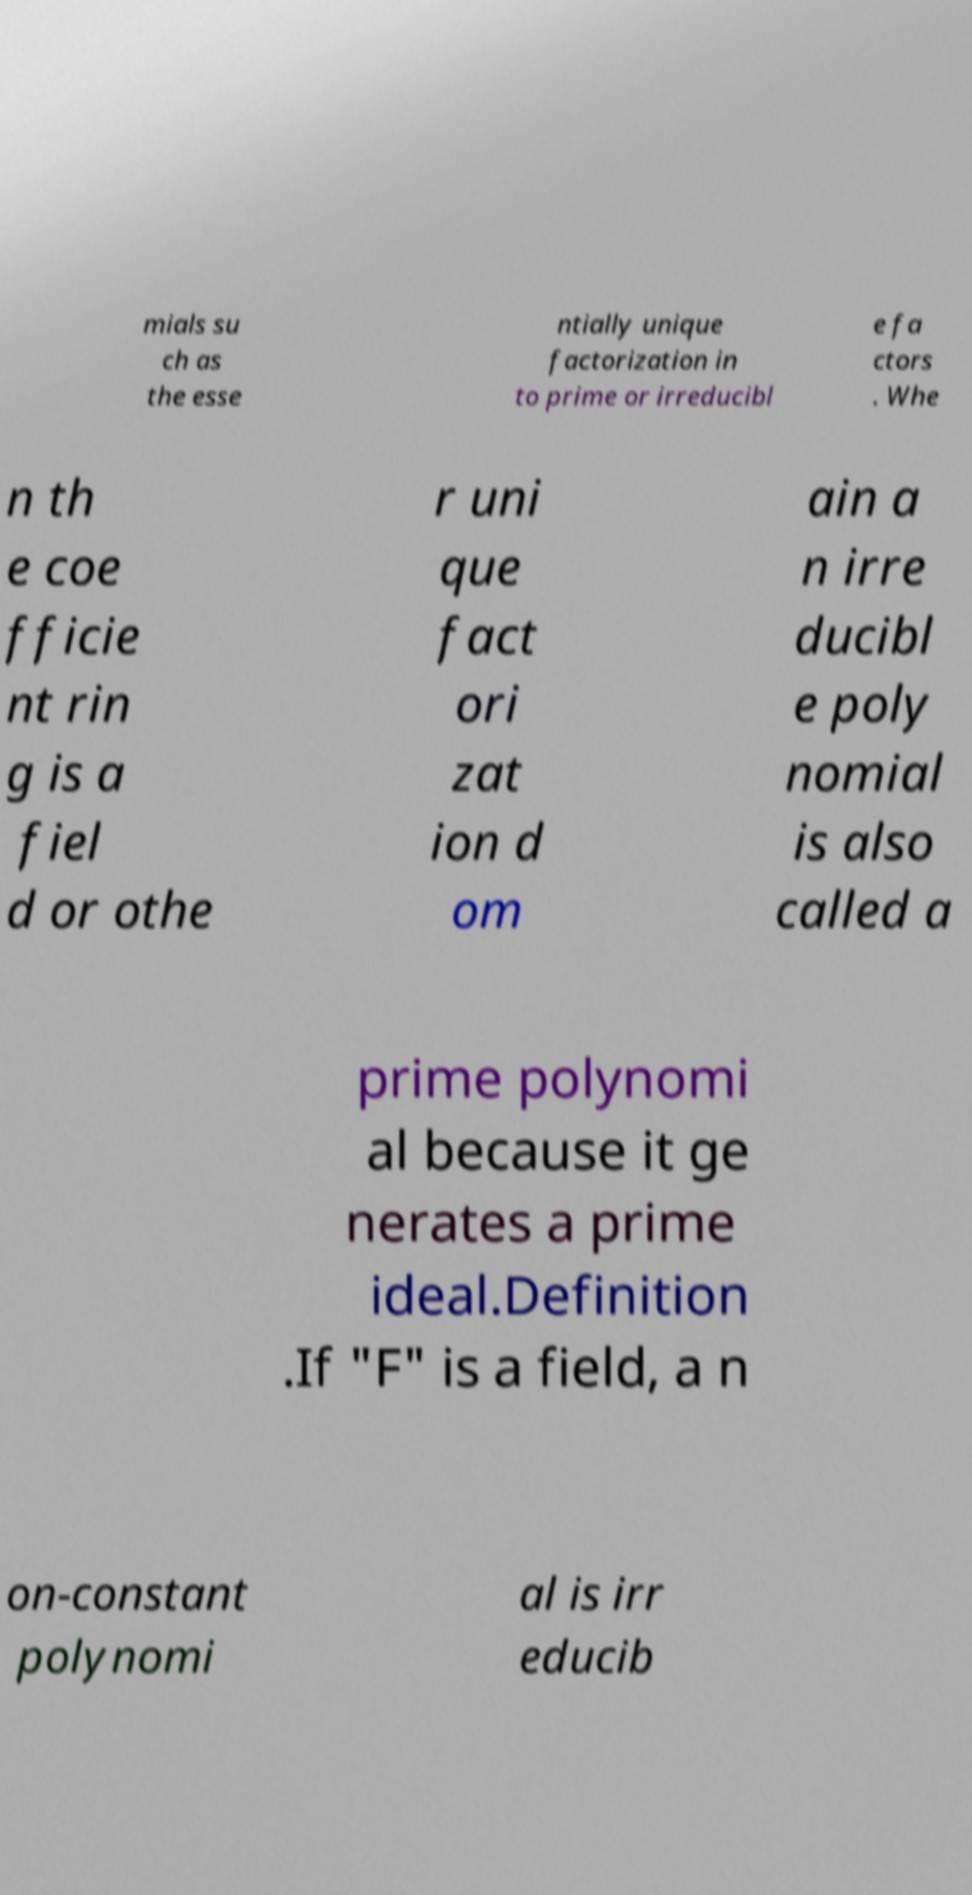Could you extract and type out the text from this image? mials su ch as the esse ntially unique factorization in to prime or irreducibl e fa ctors . Whe n th e coe fficie nt rin g is a fiel d or othe r uni que fact ori zat ion d om ain a n irre ducibl e poly nomial is also called a prime polynomi al because it ge nerates a prime ideal.Definition .If "F" is a field, a n on-constant polynomi al is irr educib 